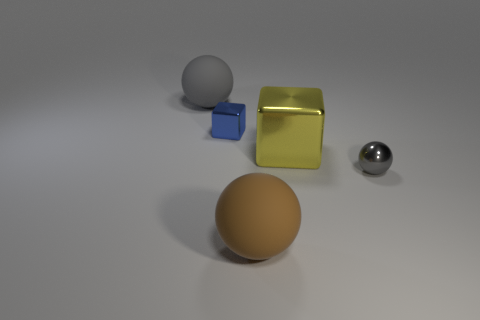There is a gray sphere left of the gray shiny ball; is it the same size as the metallic cube that is to the right of the brown matte ball?
Provide a short and direct response. Yes. There is a gray object on the right side of the gray object that is behind the small sphere; what is its material?
Make the answer very short. Metal. What number of things are either gray objects in front of the big yellow cube or matte objects?
Your response must be concise. 3. Are there the same number of gray objects that are in front of the large gray matte ball and big metal cubes that are on the right side of the gray shiny sphere?
Your response must be concise. No. What material is the big sphere that is behind the ball in front of the gray ball to the right of the large gray sphere?
Provide a succinct answer. Rubber. There is a ball that is both behind the large brown object and on the left side of the metallic sphere; what is its size?
Your answer should be very brief. Large. Is the shape of the big brown object the same as the gray shiny thing?
Ensure brevity in your answer.  Yes. What shape is the big yellow thing that is the same material as the small cube?
Your answer should be very brief. Cube. How many tiny things are either purple matte cylinders or brown rubber spheres?
Your answer should be very brief. 0. Is there a gray thing left of the ball in front of the tiny gray sphere?
Give a very brief answer. Yes. 